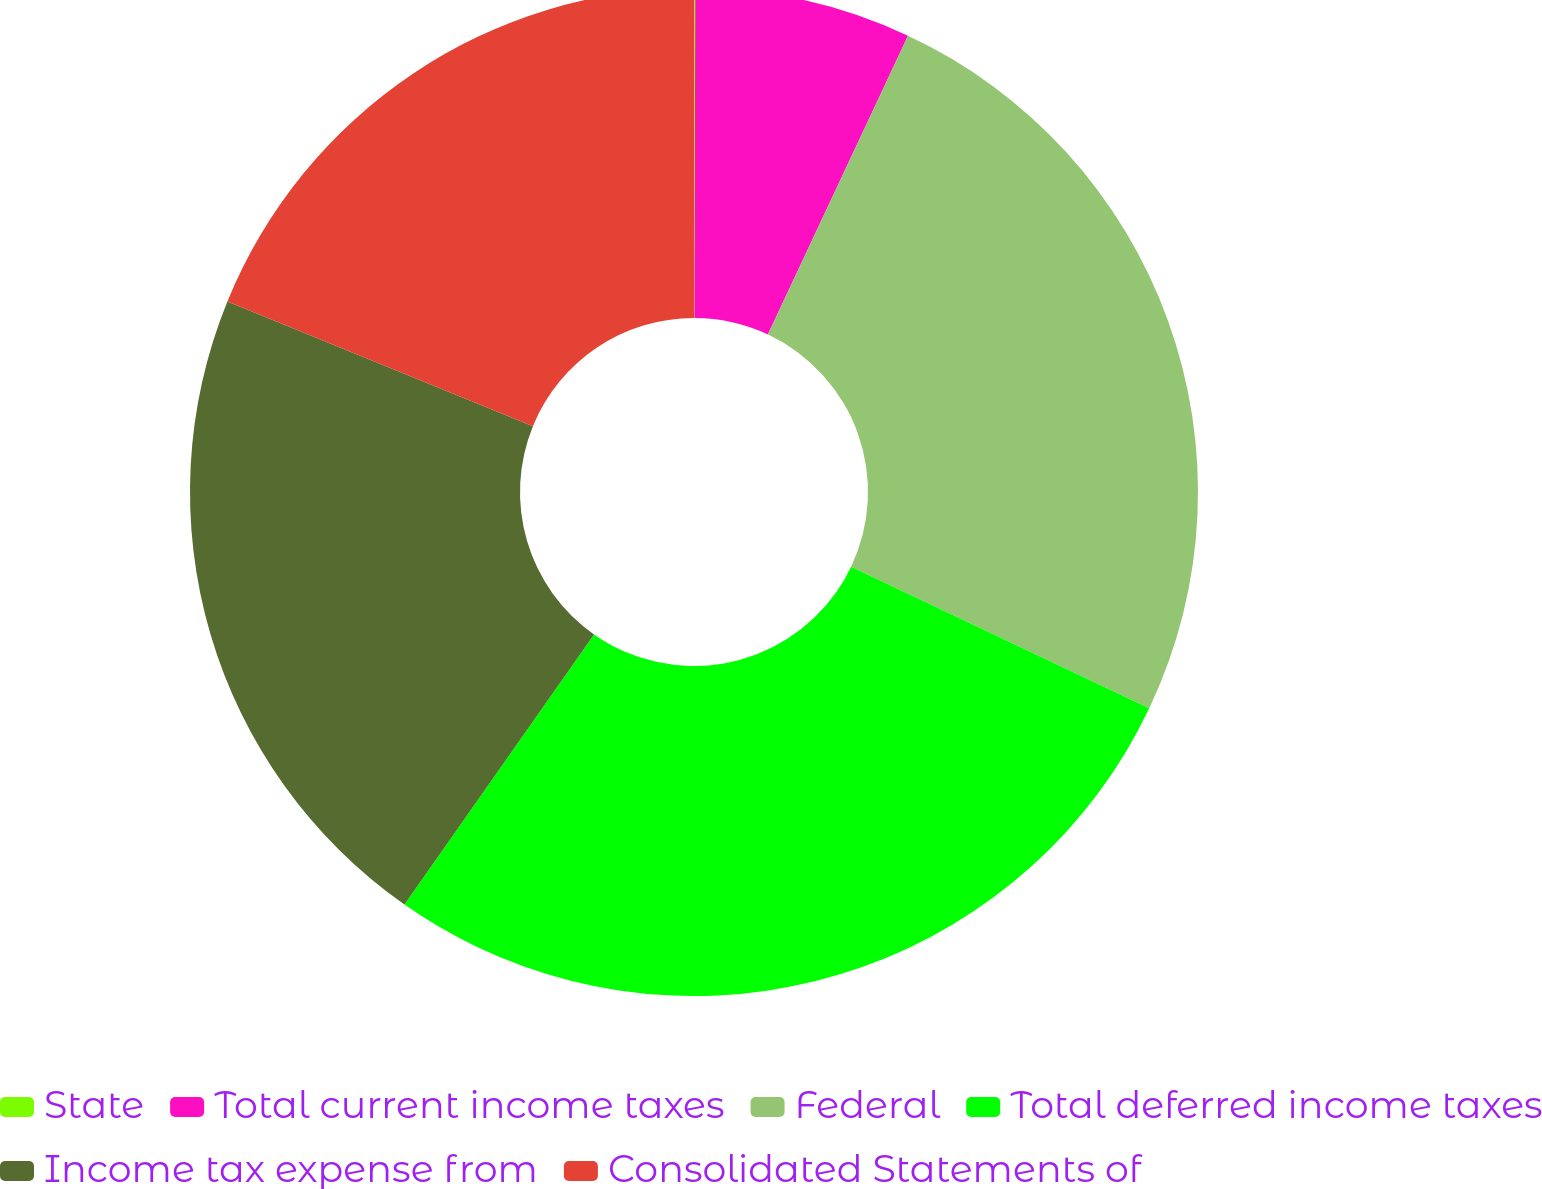Convert chart to OTSL. <chart><loc_0><loc_0><loc_500><loc_500><pie_chart><fcel>State<fcel>Total current income taxes<fcel>Federal<fcel>Total deferred income taxes<fcel>Income tax expense from<fcel>Consolidated Statements of<nl><fcel>0.04%<fcel>6.94%<fcel>25.08%<fcel>27.68%<fcel>21.43%<fcel>18.83%<nl></chart> 